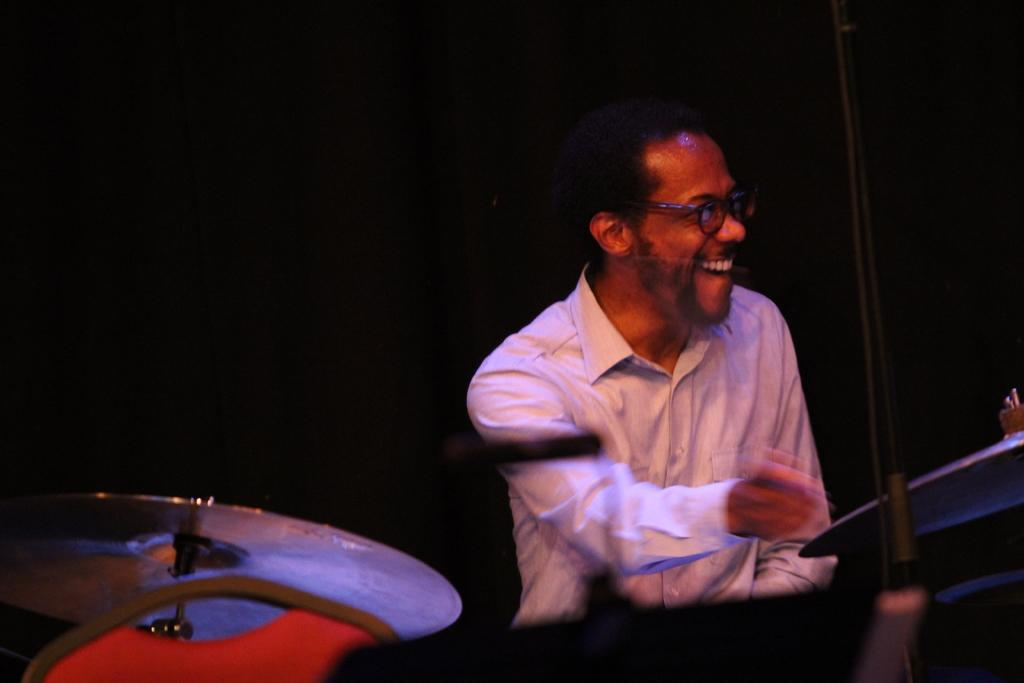Who is the main subject in the image? There is a man in the image. What is the man doing in the image? The man is sitting and playing a drum. What is the man wearing on his upper body? The man is wearing a white shirt. What type of eyewear is the man wearing? The man is wearing specks. What type of vegetable is the man using as a drumstick in the image? There is no vegetable present in the image, and the man is not using a vegetable as a drumstick. 